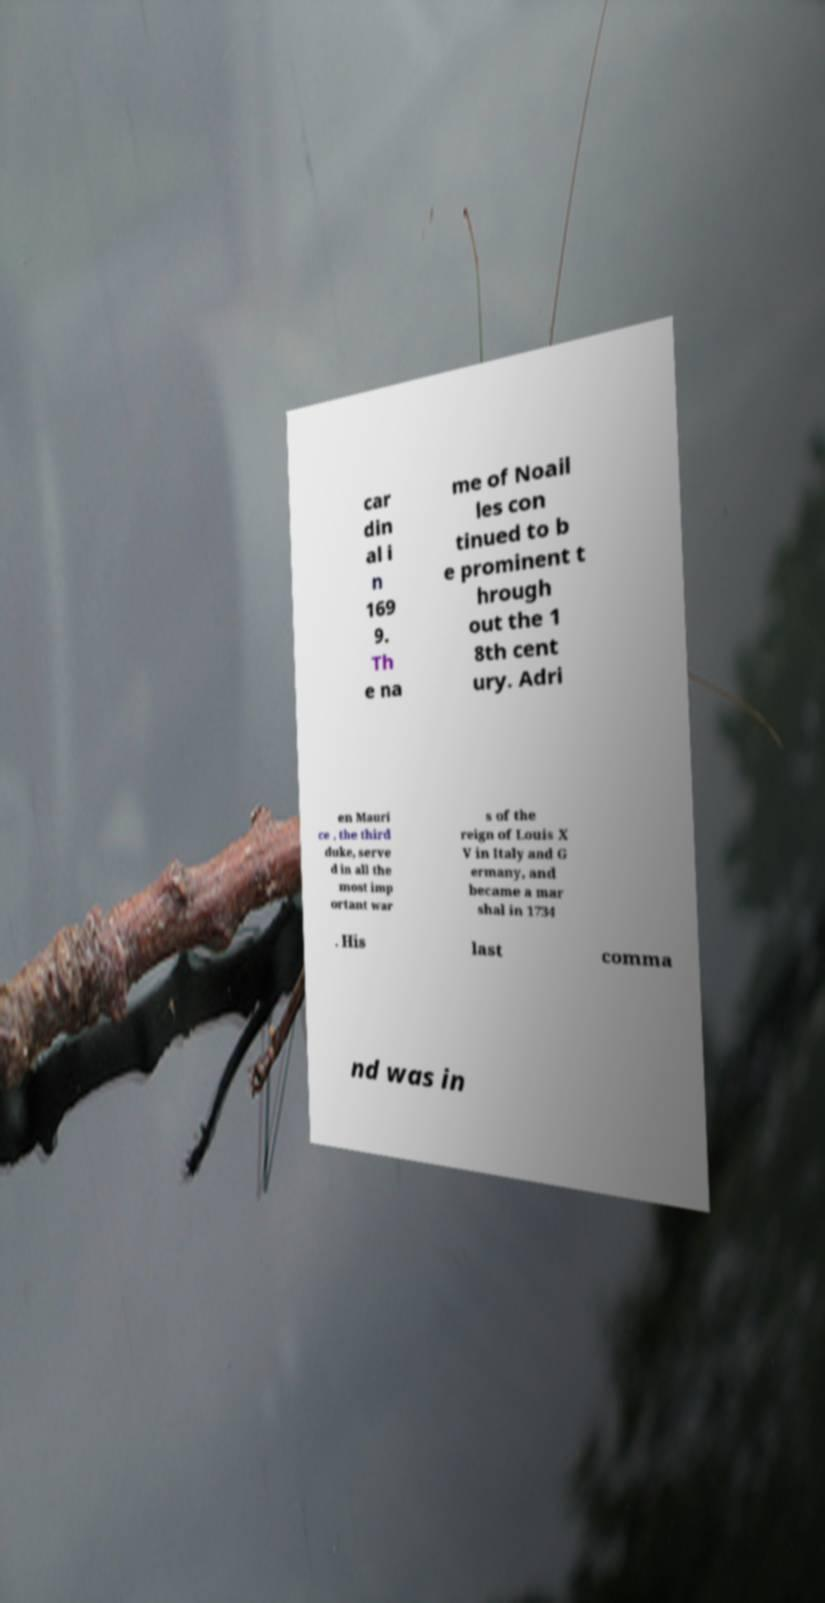Please identify and transcribe the text found in this image. car din al i n 169 9. Th e na me of Noail les con tinued to b e prominent t hrough out the 1 8th cent ury. Adri en Mauri ce , the third duke, serve d in all the most imp ortant war s of the reign of Louis X V in Italy and G ermany, and became a mar shal in 1734 . His last comma nd was in 